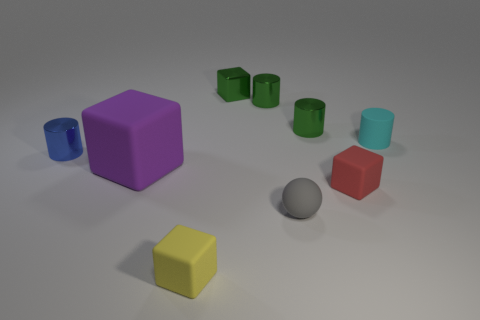What material is the sphere that is the same size as the red block?
Your answer should be compact. Rubber. What number of cubes are large things or tiny things?
Provide a succinct answer. 4. There is a blue cylinder behind the small rubber object that is to the left of the sphere; how many tiny objects are in front of it?
Your answer should be very brief. 3. There is a green object that is the same shape as the red matte object; what is its material?
Keep it short and to the point. Metal. What is the color of the matte cube that is right of the green block?
Give a very brief answer. Red. Is the red block made of the same material as the blue cylinder left of the matte sphere?
Your answer should be compact. No. What material is the purple object?
Offer a terse response. Rubber. There is a large purple object that is the same material as the small gray sphere; what is its shape?
Keep it short and to the point. Cube. How many other things are there of the same shape as the tiny blue shiny object?
Offer a terse response. 3. There is a gray thing; what number of tiny metallic objects are left of it?
Offer a very short reply. 3. 